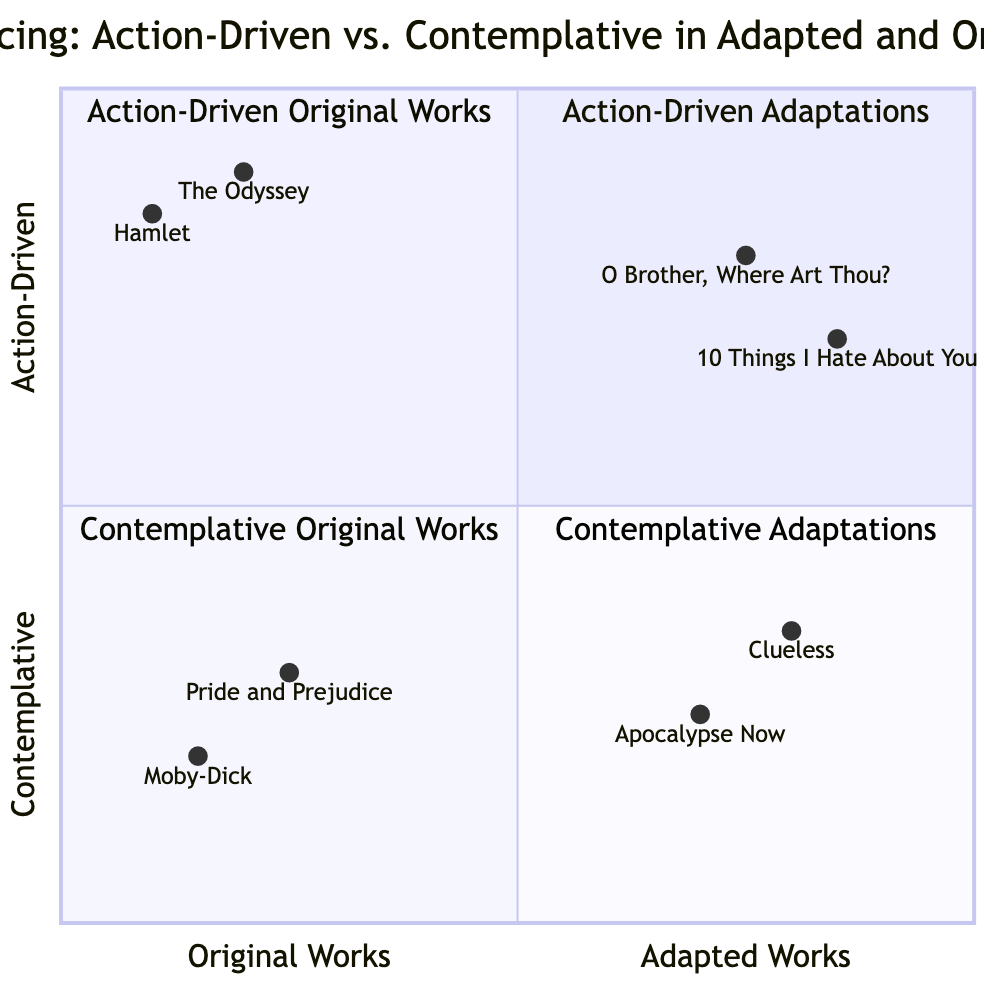What are the titles of the works in the action-driven adaptations quadrant? The action-driven adaptations quadrant contains two works: "O Brother, Where Art Thou?" and "10 Things I Hate About You". These titles can be directly noted from the text describing that specific quadrant.
Answer: O Brother, Where Art Thou?; 10 Things I Hate About You Which original work is farthest to the left in the diagram? The original work that is farthest to the left is "Moby-Dick" as it has the lowest x-axis value of 0.15. This is determined by comparing the x-axis values of the original works listed in the diagram.
Answer: Moby-Dick How many action-driven original works are depicted in the chart? The chart shows two action-driven original works: "The Odyssey" and "Hamlet". This is confirmed by directly counting the examples under the action-driven original works quadrant.
Answer: 2 Which adapted work has a higher contemplative value: "Clueless" or "Apocalypse Now"? "Clueless" has a contemplative value of 0.35, while "Apocalypse Now" has a value of 0.25, making "Clueless" the one with the higher value. Comparison of the y-axis values assigned to each adapted work leads to this conclusion.
Answer: Clueless What is the average x-axis value of the original works? To find the average x-axis value, add the x-axis values of "The Odyssey" (0.2), "Hamlet" (0.1), "Moby-Dick" (0.15), and "Pride and Prejudice" (0.25). The sum is 0.2 + 0.1 + 0.15 + 0.25 = 0.7. Then divide by the number of works (4), resulting in an average of 0.175.
Answer: 0.175 Which quadrant contains works that have a faster narrative pacing compared to the contemplative adaptations? The action-driven adaptations quadrant contains works with faster narrative pacing compared to the contemplative adaptations quadrant, which includes both "Clueless" and "Apocalypse Now". This is determined by the y-axis categorization of pacing.
Answer: Action-Driven Adaptations 